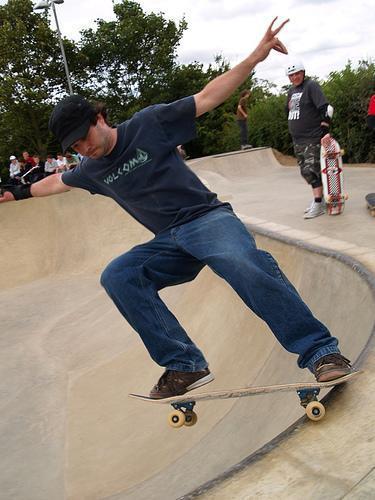How many skateboards are there?
Give a very brief answer. 2. How many hands are on the skateboard?
Give a very brief answer. 0. How many people are visible?
Give a very brief answer. 2. How many motorcycles are there?
Give a very brief answer. 0. 